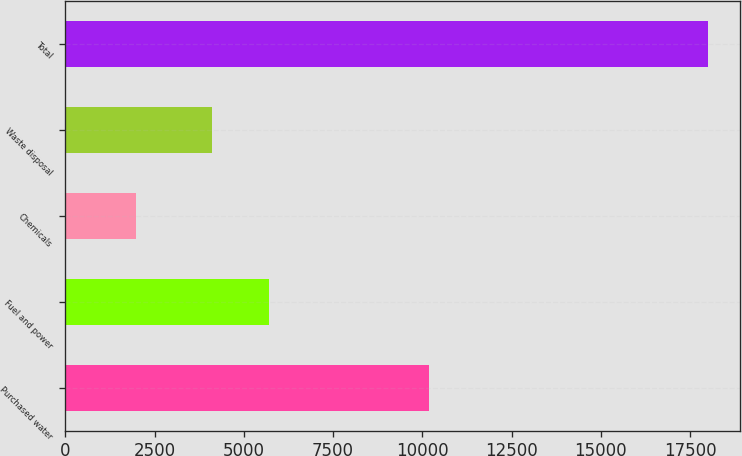<chart> <loc_0><loc_0><loc_500><loc_500><bar_chart><fcel>Purchased water<fcel>Fuel and power<fcel>Chemicals<fcel>Waste disposal<fcel>Total<nl><fcel>10182<fcel>5703.6<fcel>1971<fcel>4102<fcel>17987<nl></chart> 